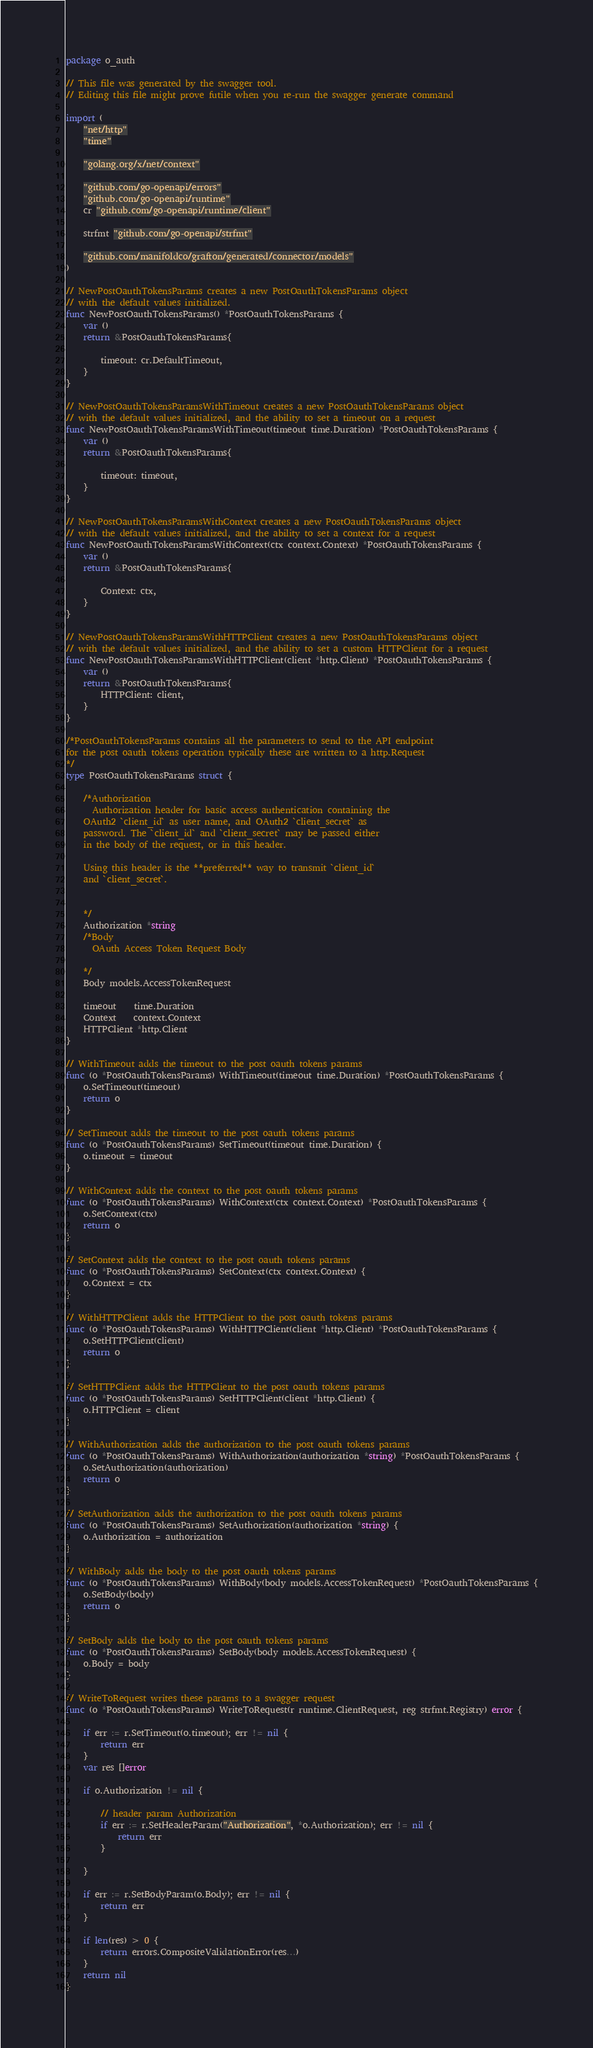Convert code to text. <code><loc_0><loc_0><loc_500><loc_500><_Go_>package o_auth

// This file was generated by the swagger tool.
// Editing this file might prove futile when you re-run the swagger generate command

import (
	"net/http"
	"time"

	"golang.org/x/net/context"

	"github.com/go-openapi/errors"
	"github.com/go-openapi/runtime"
	cr "github.com/go-openapi/runtime/client"

	strfmt "github.com/go-openapi/strfmt"

	"github.com/manifoldco/grafton/generated/connector/models"
)

// NewPostOauthTokensParams creates a new PostOauthTokensParams object
// with the default values initialized.
func NewPostOauthTokensParams() *PostOauthTokensParams {
	var ()
	return &PostOauthTokensParams{

		timeout: cr.DefaultTimeout,
	}
}

// NewPostOauthTokensParamsWithTimeout creates a new PostOauthTokensParams object
// with the default values initialized, and the ability to set a timeout on a request
func NewPostOauthTokensParamsWithTimeout(timeout time.Duration) *PostOauthTokensParams {
	var ()
	return &PostOauthTokensParams{

		timeout: timeout,
	}
}

// NewPostOauthTokensParamsWithContext creates a new PostOauthTokensParams object
// with the default values initialized, and the ability to set a context for a request
func NewPostOauthTokensParamsWithContext(ctx context.Context) *PostOauthTokensParams {
	var ()
	return &PostOauthTokensParams{

		Context: ctx,
	}
}

// NewPostOauthTokensParamsWithHTTPClient creates a new PostOauthTokensParams object
// with the default values initialized, and the ability to set a custom HTTPClient for a request
func NewPostOauthTokensParamsWithHTTPClient(client *http.Client) *PostOauthTokensParams {
	var ()
	return &PostOauthTokensParams{
		HTTPClient: client,
	}
}

/*PostOauthTokensParams contains all the parameters to send to the API endpoint
for the post oauth tokens operation typically these are written to a http.Request
*/
type PostOauthTokensParams struct {

	/*Authorization
	  Authorization header for basic access authentication containing the
	OAuth2 `client_id` as user name, and OAuth2 `client_secret` as
	password. The `client_id` and `client_secret` may be passed either
	in the body of the request, or in this header.

	Using this header is the **preferred** way to transmit `client_id`
	and `client_secret`.


	*/
	Authorization *string
	/*Body
	  OAuth Access Token Request Body

	*/
	Body models.AccessTokenRequest

	timeout    time.Duration
	Context    context.Context
	HTTPClient *http.Client
}

// WithTimeout adds the timeout to the post oauth tokens params
func (o *PostOauthTokensParams) WithTimeout(timeout time.Duration) *PostOauthTokensParams {
	o.SetTimeout(timeout)
	return o
}

// SetTimeout adds the timeout to the post oauth tokens params
func (o *PostOauthTokensParams) SetTimeout(timeout time.Duration) {
	o.timeout = timeout
}

// WithContext adds the context to the post oauth tokens params
func (o *PostOauthTokensParams) WithContext(ctx context.Context) *PostOauthTokensParams {
	o.SetContext(ctx)
	return o
}

// SetContext adds the context to the post oauth tokens params
func (o *PostOauthTokensParams) SetContext(ctx context.Context) {
	o.Context = ctx
}

// WithHTTPClient adds the HTTPClient to the post oauth tokens params
func (o *PostOauthTokensParams) WithHTTPClient(client *http.Client) *PostOauthTokensParams {
	o.SetHTTPClient(client)
	return o
}

// SetHTTPClient adds the HTTPClient to the post oauth tokens params
func (o *PostOauthTokensParams) SetHTTPClient(client *http.Client) {
	o.HTTPClient = client
}

// WithAuthorization adds the authorization to the post oauth tokens params
func (o *PostOauthTokensParams) WithAuthorization(authorization *string) *PostOauthTokensParams {
	o.SetAuthorization(authorization)
	return o
}

// SetAuthorization adds the authorization to the post oauth tokens params
func (o *PostOauthTokensParams) SetAuthorization(authorization *string) {
	o.Authorization = authorization
}

// WithBody adds the body to the post oauth tokens params
func (o *PostOauthTokensParams) WithBody(body models.AccessTokenRequest) *PostOauthTokensParams {
	o.SetBody(body)
	return o
}

// SetBody adds the body to the post oauth tokens params
func (o *PostOauthTokensParams) SetBody(body models.AccessTokenRequest) {
	o.Body = body
}

// WriteToRequest writes these params to a swagger request
func (o *PostOauthTokensParams) WriteToRequest(r runtime.ClientRequest, reg strfmt.Registry) error {

	if err := r.SetTimeout(o.timeout); err != nil {
		return err
	}
	var res []error

	if o.Authorization != nil {

		// header param Authorization
		if err := r.SetHeaderParam("Authorization", *o.Authorization); err != nil {
			return err
		}

	}

	if err := r.SetBodyParam(o.Body); err != nil {
		return err
	}

	if len(res) > 0 {
		return errors.CompositeValidationError(res...)
	}
	return nil
}
</code> 